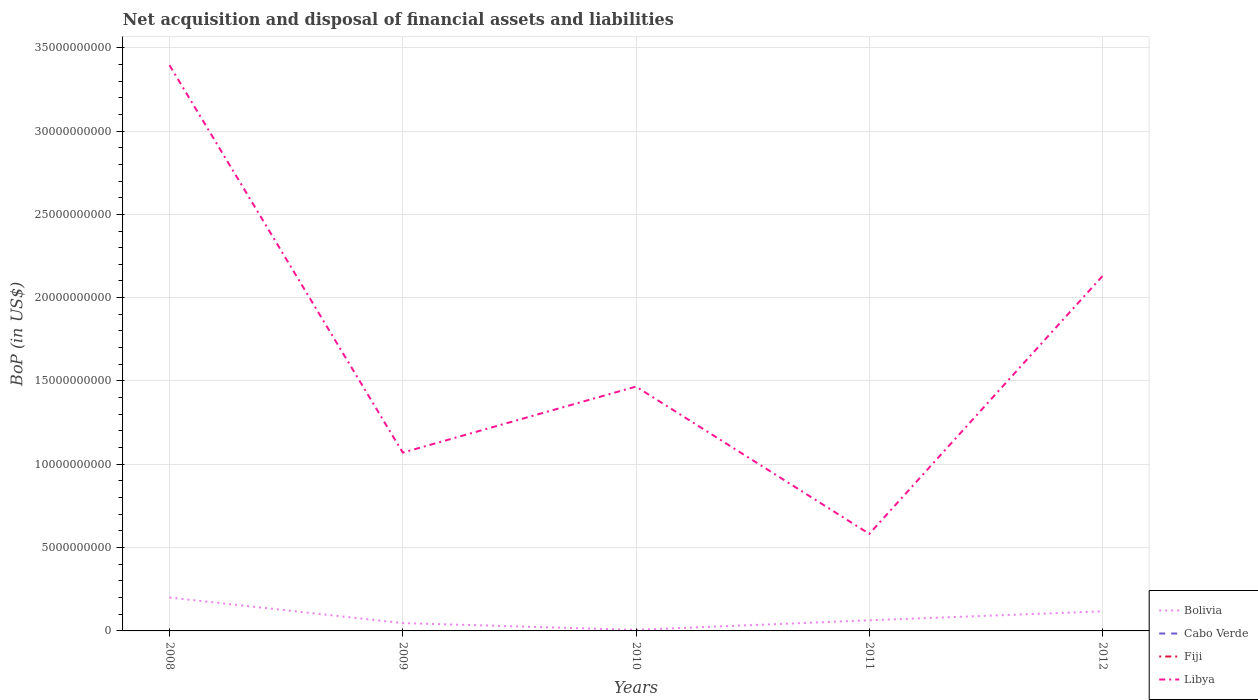How many different coloured lines are there?
Provide a succinct answer. 2. Is the number of lines equal to the number of legend labels?
Offer a terse response. No. Across all years, what is the maximum Balance of Payments in Fiji?
Your response must be concise. 0. What is the total Balance of Payments in Libya in the graph?
Make the answer very short. 4.88e+09. What is the difference between the highest and the second highest Balance of Payments in Bolivia?
Provide a short and direct response. 1.94e+09. What is the difference between the highest and the lowest Balance of Payments in Cabo Verde?
Offer a terse response. 0. How many lines are there?
Your answer should be compact. 2. What is the difference between two consecutive major ticks on the Y-axis?
Make the answer very short. 5.00e+09. Are the values on the major ticks of Y-axis written in scientific E-notation?
Make the answer very short. No. Where does the legend appear in the graph?
Your answer should be compact. Bottom right. How many legend labels are there?
Offer a terse response. 4. How are the legend labels stacked?
Make the answer very short. Vertical. What is the title of the graph?
Ensure brevity in your answer.  Net acquisition and disposal of financial assets and liabilities. What is the label or title of the Y-axis?
Give a very brief answer. BoP (in US$). What is the BoP (in US$) of Bolivia in 2008?
Offer a terse response. 2.00e+09. What is the BoP (in US$) in Fiji in 2008?
Give a very brief answer. 0. What is the BoP (in US$) of Libya in 2008?
Your answer should be compact. 3.39e+1. What is the BoP (in US$) in Bolivia in 2009?
Ensure brevity in your answer.  4.71e+08. What is the BoP (in US$) of Libya in 2009?
Keep it short and to the point. 1.07e+1. What is the BoP (in US$) in Bolivia in 2010?
Offer a very short reply. 6.43e+07. What is the BoP (in US$) in Cabo Verde in 2010?
Your response must be concise. 0. What is the BoP (in US$) of Fiji in 2010?
Keep it short and to the point. 0. What is the BoP (in US$) of Libya in 2010?
Your answer should be very brief. 1.47e+1. What is the BoP (in US$) in Bolivia in 2011?
Ensure brevity in your answer.  6.38e+08. What is the BoP (in US$) of Libya in 2011?
Your answer should be very brief. 5.83e+09. What is the BoP (in US$) in Bolivia in 2012?
Keep it short and to the point. 1.18e+09. What is the BoP (in US$) of Cabo Verde in 2012?
Provide a short and direct response. 0. What is the BoP (in US$) in Libya in 2012?
Make the answer very short. 2.13e+1. Across all years, what is the maximum BoP (in US$) in Bolivia?
Your answer should be compact. 2.00e+09. Across all years, what is the maximum BoP (in US$) in Libya?
Your answer should be compact. 3.39e+1. Across all years, what is the minimum BoP (in US$) of Bolivia?
Your answer should be compact. 6.43e+07. Across all years, what is the minimum BoP (in US$) in Libya?
Keep it short and to the point. 5.83e+09. What is the total BoP (in US$) in Bolivia in the graph?
Keep it short and to the point. 4.35e+09. What is the total BoP (in US$) of Libya in the graph?
Your answer should be compact. 8.64e+1. What is the difference between the BoP (in US$) in Bolivia in 2008 and that in 2009?
Ensure brevity in your answer.  1.53e+09. What is the difference between the BoP (in US$) of Libya in 2008 and that in 2009?
Provide a succinct answer. 2.32e+1. What is the difference between the BoP (in US$) in Bolivia in 2008 and that in 2010?
Offer a very short reply. 1.94e+09. What is the difference between the BoP (in US$) in Libya in 2008 and that in 2010?
Give a very brief answer. 1.93e+1. What is the difference between the BoP (in US$) of Bolivia in 2008 and that in 2011?
Provide a short and direct response. 1.37e+09. What is the difference between the BoP (in US$) of Libya in 2008 and that in 2011?
Make the answer very short. 2.81e+1. What is the difference between the BoP (in US$) of Bolivia in 2008 and that in 2012?
Your answer should be very brief. 8.28e+08. What is the difference between the BoP (in US$) in Libya in 2008 and that in 2012?
Give a very brief answer. 1.26e+1. What is the difference between the BoP (in US$) of Bolivia in 2009 and that in 2010?
Provide a succinct answer. 4.06e+08. What is the difference between the BoP (in US$) of Libya in 2009 and that in 2010?
Ensure brevity in your answer.  -3.96e+09. What is the difference between the BoP (in US$) of Bolivia in 2009 and that in 2011?
Make the answer very short. -1.67e+08. What is the difference between the BoP (in US$) of Libya in 2009 and that in 2011?
Make the answer very short. 4.88e+09. What is the difference between the BoP (in US$) of Bolivia in 2009 and that in 2012?
Your response must be concise. -7.05e+08. What is the difference between the BoP (in US$) of Libya in 2009 and that in 2012?
Give a very brief answer. -1.06e+1. What is the difference between the BoP (in US$) in Bolivia in 2010 and that in 2011?
Provide a succinct answer. -5.74e+08. What is the difference between the BoP (in US$) in Libya in 2010 and that in 2011?
Give a very brief answer. 8.84e+09. What is the difference between the BoP (in US$) of Bolivia in 2010 and that in 2012?
Give a very brief answer. -1.11e+09. What is the difference between the BoP (in US$) in Libya in 2010 and that in 2012?
Offer a very short reply. -6.64e+09. What is the difference between the BoP (in US$) of Bolivia in 2011 and that in 2012?
Give a very brief answer. -5.38e+08. What is the difference between the BoP (in US$) in Libya in 2011 and that in 2012?
Make the answer very short. -1.55e+1. What is the difference between the BoP (in US$) in Bolivia in 2008 and the BoP (in US$) in Libya in 2009?
Your answer should be very brief. -8.70e+09. What is the difference between the BoP (in US$) of Bolivia in 2008 and the BoP (in US$) of Libya in 2010?
Provide a succinct answer. -1.27e+1. What is the difference between the BoP (in US$) of Bolivia in 2008 and the BoP (in US$) of Libya in 2011?
Offer a terse response. -3.82e+09. What is the difference between the BoP (in US$) of Bolivia in 2008 and the BoP (in US$) of Libya in 2012?
Your answer should be very brief. -1.93e+1. What is the difference between the BoP (in US$) in Bolivia in 2009 and the BoP (in US$) in Libya in 2010?
Your answer should be very brief. -1.42e+1. What is the difference between the BoP (in US$) of Bolivia in 2009 and the BoP (in US$) of Libya in 2011?
Your response must be concise. -5.35e+09. What is the difference between the BoP (in US$) of Bolivia in 2009 and the BoP (in US$) of Libya in 2012?
Keep it short and to the point. -2.08e+1. What is the difference between the BoP (in US$) of Bolivia in 2010 and the BoP (in US$) of Libya in 2011?
Keep it short and to the point. -5.76e+09. What is the difference between the BoP (in US$) of Bolivia in 2010 and the BoP (in US$) of Libya in 2012?
Give a very brief answer. -2.12e+1. What is the difference between the BoP (in US$) of Bolivia in 2011 and the BoP (in US$) of Libya in 2012?
Give a very brief answer. -2.07e+1. What is the average BoP (in US$) in Bolivia per year?
Offer a very short reply. 8.70e+08. What is the average BoP (in US$) in Fiji per year?
Your answer should be compact. 0. What is the average BoP (in US$) in Libya per year?
Give a very brief answer. 1.73e+1. In the year 2008, what is the difference between the BoP (in US$) in Bolivia and BoP (in US$) in Libya?
Ensure brevity in your answer.  -3.19e+1. In the year 2009, what is the difference between the BoP (in US$) in Bolivia and BoP (in US$) in Libya?
Offer a very short reply. -1.02e+1. In the year 2010, what is the difference between the BoP (in US$) in Bolivia and BoP (in US$) in Libya?
Offer a very short reply. -1.46e+1. In the year 2011, what is the difference between the BoP (in US$) of Bolivia and BoP (in US$) of Libya?
Keep it short and to the point. -5.19e+09. In the year 2012, what is the difference between the BoP (in US$) of Bolivia and BoP (in US$) of Libya?
Provide a succinct answer. -2.01e+1. What is the ratio of the BoP (in US$) in Bolivia in 2008 to that in 2009?
Your response must be concise. 4.26. What is the ratio of the BoP (in US$) of Libya in 2008 to that in 2009?
Your response must be concise. 3.17. What is the ratio of the BoP (in US$) of Bolivia in 2008 to that in 2010?
Give a very brief answer. 31.17. What is the ratio of the BoP (in US$) of Libya in 2008 to that in 2010?
Provide a short and direct response. 2.32. What is the ratio of the BoP (in US$) of Bolivia in 2008 to that in 2011?
Make the answer very short. 3.14. What is the ratio of the BoP (in US$) in Libya in 2008 to that in 2011?
Your answer should be compact. 5.83. What is the ratio of the BoP (in US$) of Bolivia in 2008 to that in 2012?
Your answer should be very brief. 1.7. What is the ratio of the BoP (in US$) in Libya in 2008 to that in 2012?
Provide a succinct answer. 1.59. What is the ratio of the BoP (in US$) in Bolivia in 2009 to that in 2010?
Offer a very short reply. 7.32. What is the ratio of the BoP (in US$) in Libya in 2009 to that in 2010?
Your answer should be compact. 0.73. What is the ratio of the BoP (in US$) in Bolivia in 2009 to that in 2011?
Your response must be concise. 0.74. What is the ratio of the BoP (in US$) in Libya in 2009 to that in 2011?
Provide a succinct answer. 1.84. What is the ratio of the BoP (in US$) in Bolivia in 2009 to that in 2012?
Offer a very short reply. 0.4. What is the ratio of the BoP (in US$) of Libya in 2009 to that in 2012?
Ensure brevity in your answer.  0.5. What is the ratio of the BoP (in US$) of Bolivia in 2010 to that in 2011?
Provide a succinct answer. 0.1. What is the ratio of the BoP (in US$) in Libya in 2010 to that in 2011?
Provide a succinct answer. 2.52. What is the ratio of the BoP (in US$) of Bolivia in 2010 to that in 2012?
Ensure brevity in your answer.  0.05. What is the ratio of the BoP (in US$) of Libya in 2010 to that in 2012?
Offer a very short reply. 0.69. What is the ratio of the BoP (in US$) in Bolivia in 2011 to that in 2012?
Provide a short and direct response. 0.54. What is the ratio of the BoP (in US$) in Libya in 2011 to that in 2012?
Give a very brief answer. 0.27. What is the difference between the highest and the second highest BoP (in US$) of Bolivia?
Your answer should be compact. 8.28e+08. What is the difference between the highest and the second highest BoP (in US$) in Libya?
Provide a succinct answer. 1.26e+1. What is the difference between the highest and the lowest BoP (in US$) of Bolivia?
Your answer should be very brief. 1.94e+09. What is the difference between the highest and the lowest BoP (in US$) of Libya?
Keep it short and to the point. 2.81e+1. 